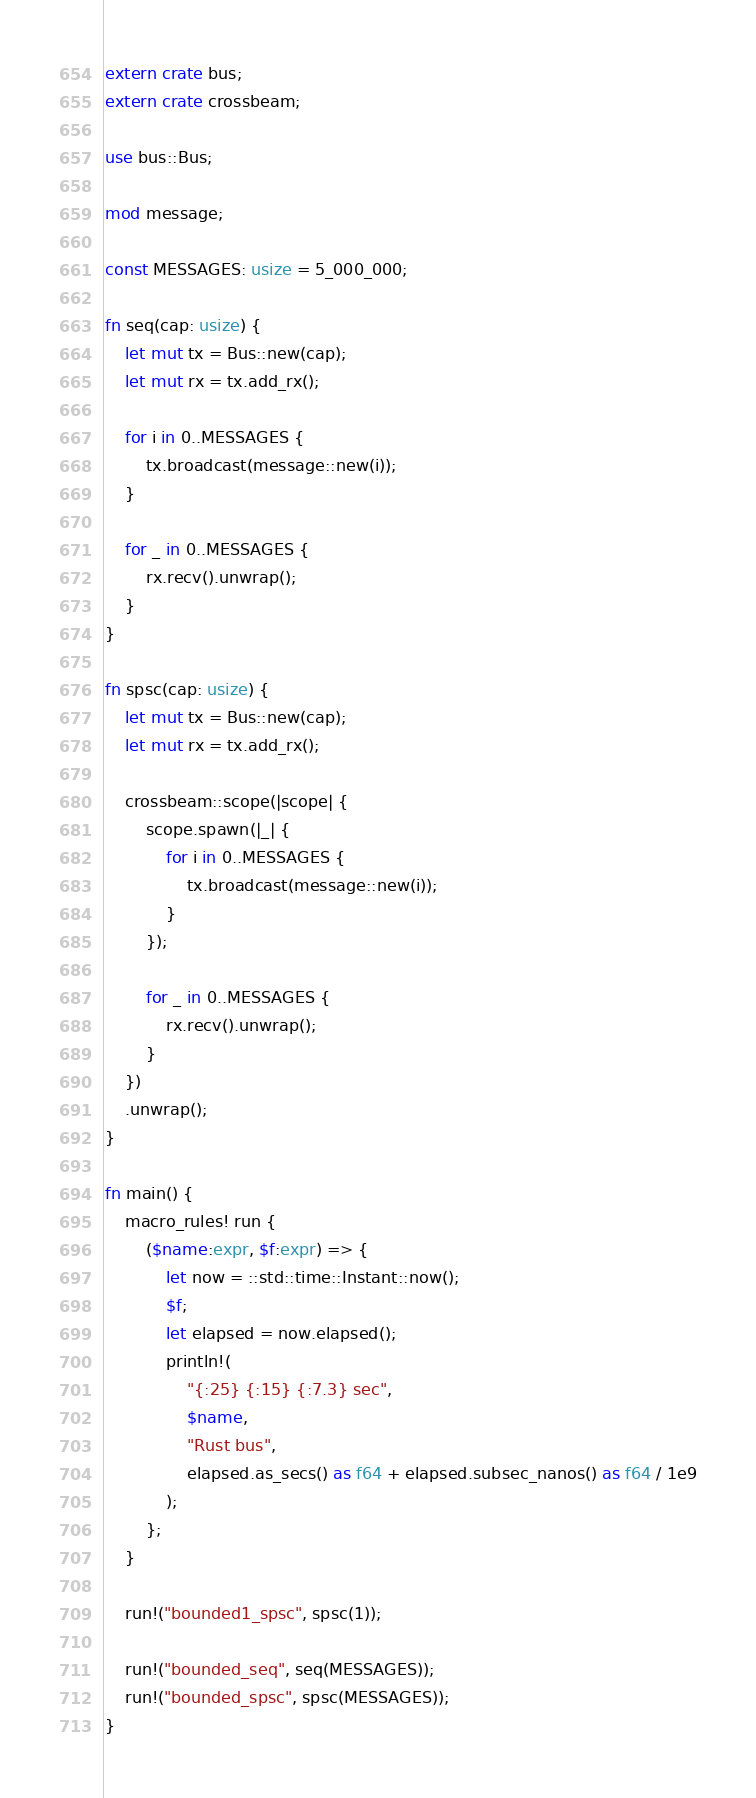<code> <loc_0><loc_0><loc_500><loc_500><_Rust_>extern crate bus;
extern crate crossbeam;

use bus::Bus;

mod message;

const MESSAGES: usize = 5_000_000;

fn seq(cap: usize) {
    let mut tx = Bus::new(cap);
    let mut rx = tx.add_rx();

    for i in 0..MESSAGES {
        tx.broadcast(message::new(i));
    }

    for _ in 0..MESSAGES {
        rx.recv().unwrap();
    }
}

fn spsc(cap: usize) {
    let mut tx = Bus::new(cap);
    let mut rx = tx.add_rx();

    crossbeam::scope(|scope| {
        scope.spawn(|_| {
            for i in 0..MESSAGES {
                tx.broadcast(message::new(i));
            }
        });

        for _ in 0..MESSAGES {
            rx.recv().unwrap();
        }
    })
    .unwrap();
}

fn main() {
    macro_rules! run {
        ($name:expr, $f:expr) => {
            let now = ::std::time::Instant::now();
            $f;
            let elapsed = now.elapsed();
            println!(
                "{:25} {:15} {:7.3} sec",
                $name,
                "Rust bus",
                elapsed.as_secs() as f64 + elapsed.subsec_nanos() as f64 / 1e9
            );
        };
    }

    run!("bounded1_spsc", spsc(1));

    run!("bounded_seq", seq(MESSAGES));
    run!("bounded_spsc", spsc(MESSAGES));
}
</code> 